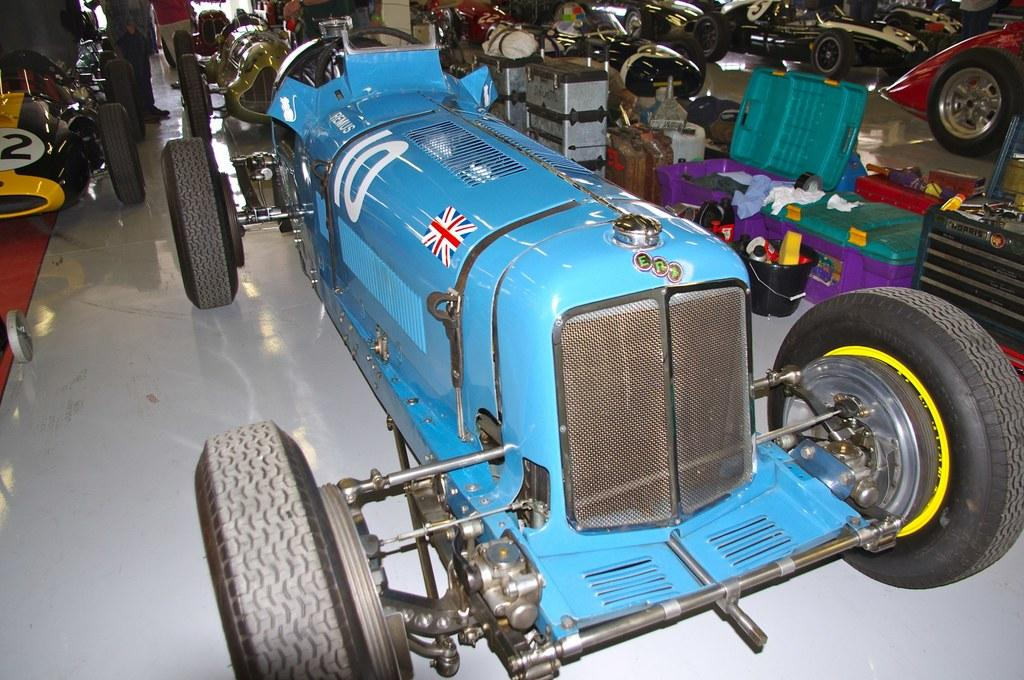What type of vehicles are on the floor in the image? There are race cars on the floor in the image. What else can be seen in the image besides the race cars? There are boxes with items and buckets with items in the image. Can you describe the contents of the boxes and buckets? The facts provided do not specify the contents of the boxes and buckets, so we cannot describe them. Are there any other objects present in the image? Yes, there are other objects present in the image, but their specific nature is not mentioned in the provided facts. What type of string is being used to control the race cars in the image? There is no string present in the image, and the race cars are not being controlled by any visible means. 